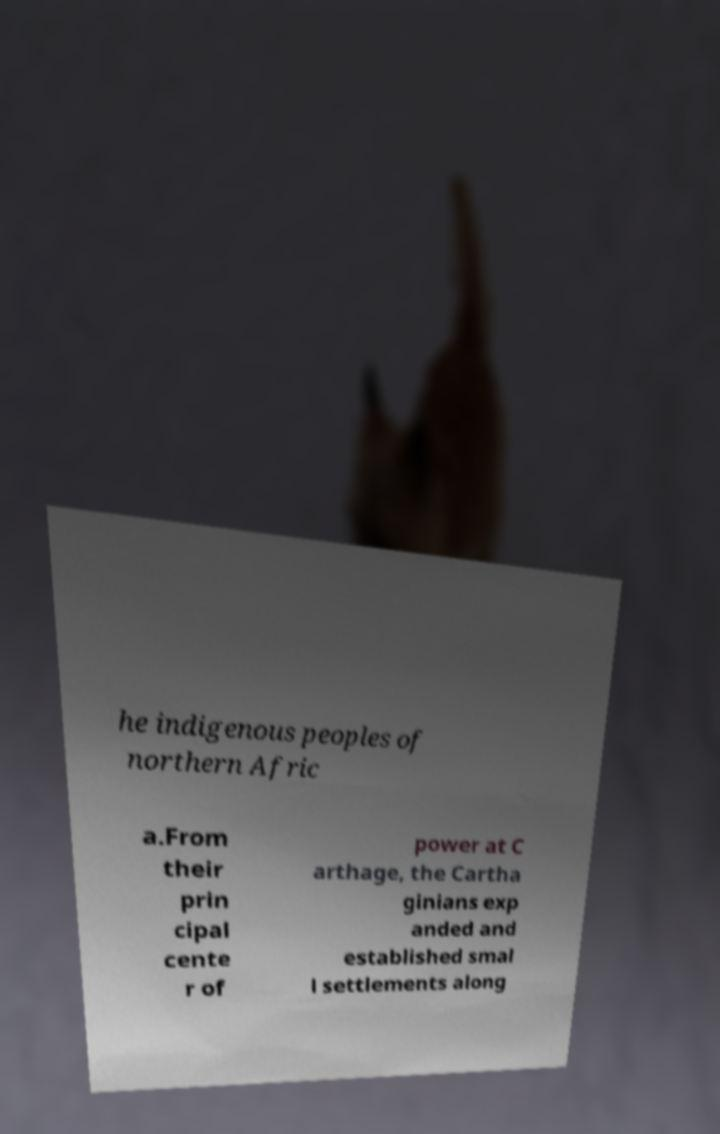Can you read and provide the text displayed in the image?This photo seems to have some interesting text. Can you extract and type it out for me? he indigenous peoples of northern Afric a.From their prin cipal cente r of power at C arthage, the Cartha ginians exp anded and established smal l settlements along 